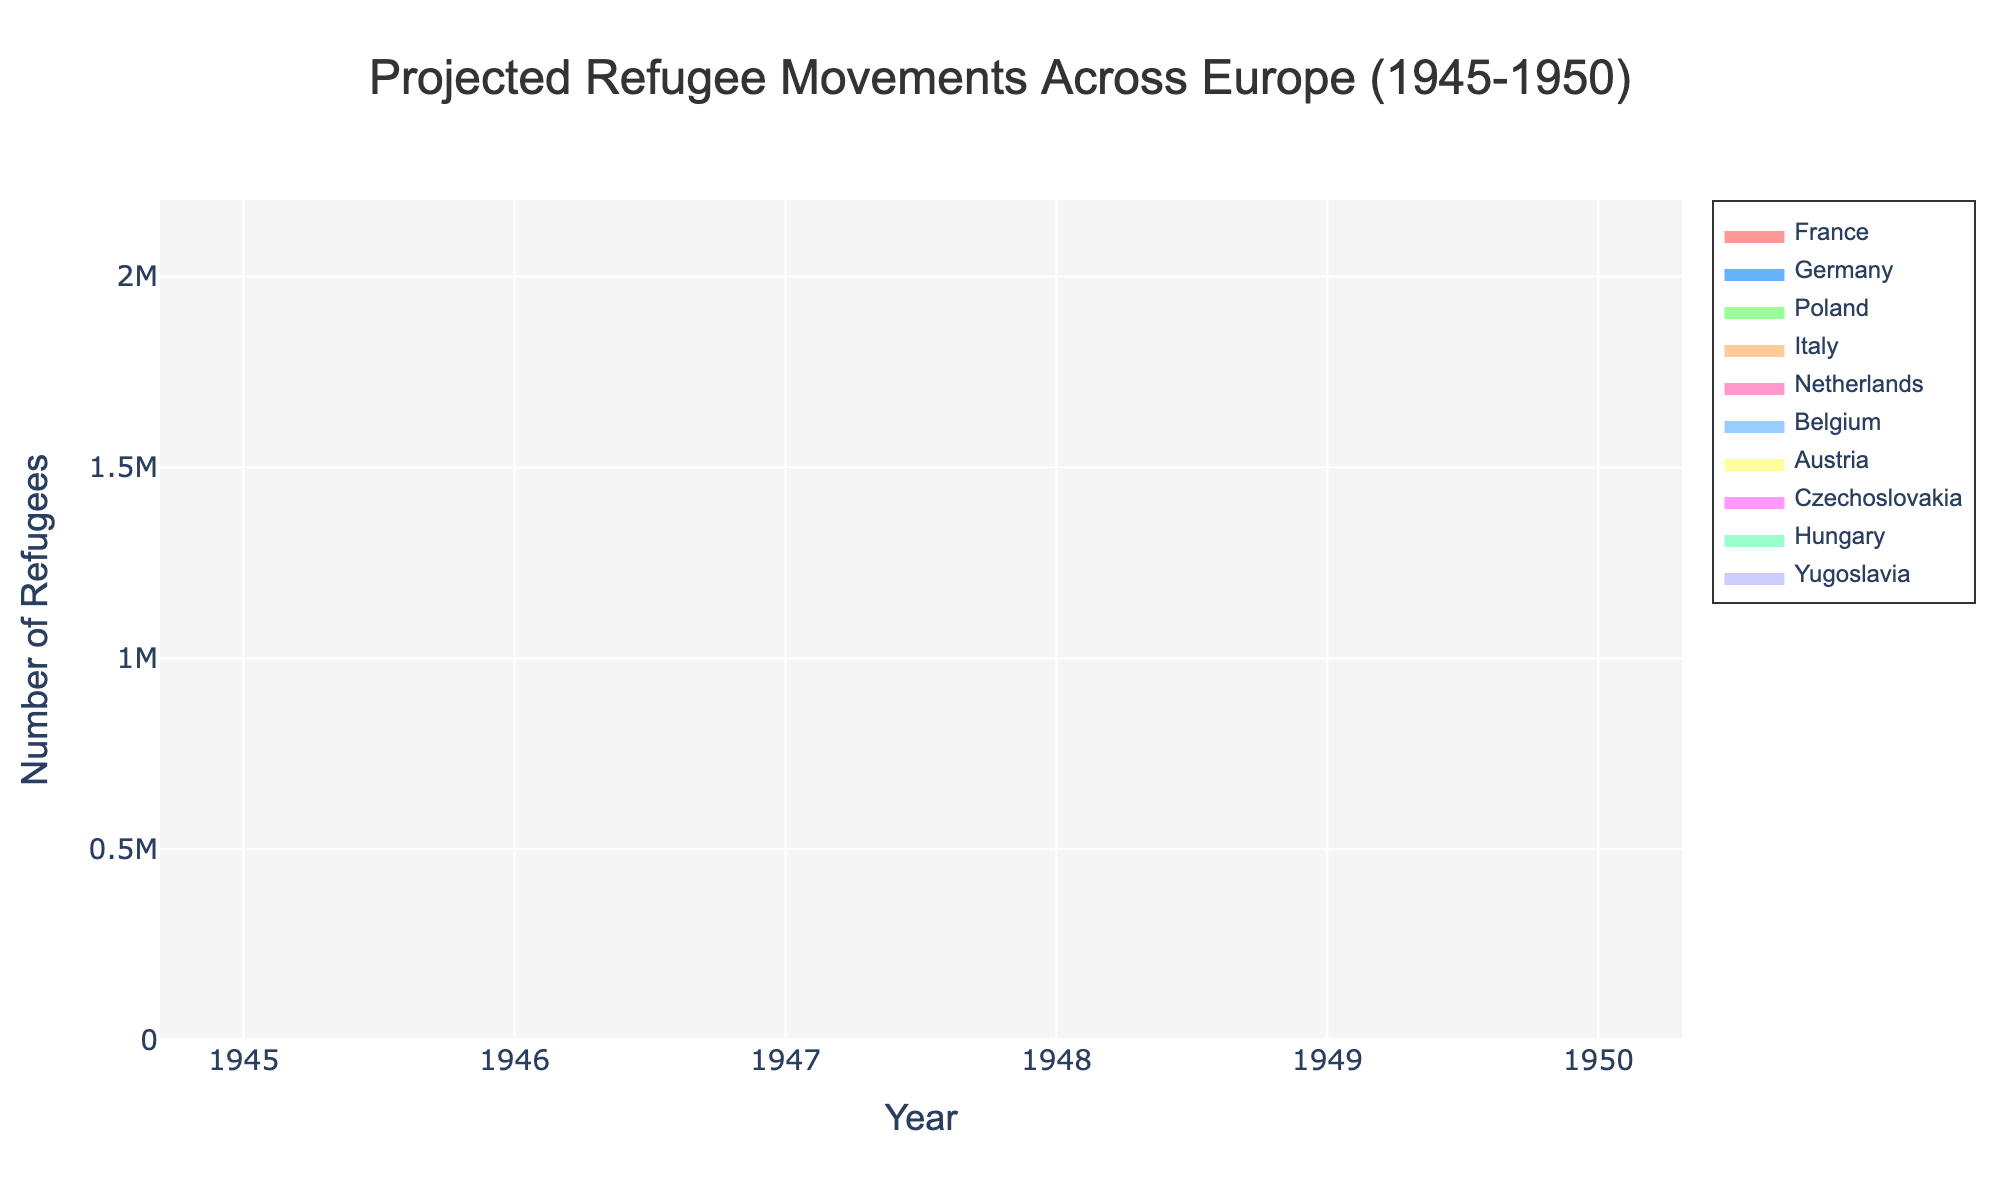What is the total number of refugees in Germany in 1947? In the 1947 column, the number for Germany is 1,600,000.
Answer: 1,600,000 Which country had the lowest number of refugees in 1950? In the 1950 column, Belgium and Italy both share the lowest value of 50,000. This can be cross-validated by scanning all values in the 1950 column.
Answer: Belgium and Italy What is the trend for the number of refugees in France from 1945 to 1950? By examining the data points for France from 1945 to 1950 (500,000; 450,000; 400,000; 350,000; 300,000; 250,000), we notice a consistent decrease.
Answer: A consistent decrease Which country had the most significant decrease in the number of refugees from 1945 to 1950? Subtract the number of refugees in 1950 from the number in 1945 for each country: France (250,000), Germany (1,000,000), Poland (1,000,000), Italy (250,000), Netherlands (100,000), Belgium (100,000), Austria (250,000), Czechoslovakia (150,000), Hungary (150,000), Yugoslavia (150,000). Germany and Poland both have the largest decrease of 1,000,000.
Answer: Germany and Poland How many refugees were in Italy and Poland combined in 1948? For 1948, add the number of refugees in Italy (150,000) and Poland (900,000): 150,000 + 900,000 = 1,050,000.
Answer: 1,050,000 Between France and Austria, which country had fewer refugees in 1949? In 1949, France had 300,000 refugees, and Austria had 200,000. Austria had fewer refugees.
Answer: Austria Which year saw the most significant drop in the number of refugees in Czechoslovakia? Calculate the yearly differences for Czechoslovakia: (250,000 - 220,000) = 30,000 (1945-1946), (220,000 - 190,000) = 30,000 (1946-1947), (190,000 - 160,000) = 30,000 (1947-1948), (160,000 - 130,000) = 30,000 (1948-1949), (130,000 - 100,000) = 30,000 (1949-1950). Each year shows an equal drop of 30,000.
Answer: Each year shows an equal drop of 30,000 In which year did the number of refugees in Hungary drop below 200,000? By checking the numbers for Hungary: 1945 (300,000), 1946 (270,000), 1947 (240,000), 1948 (210,000), 1949 (180,000), the number drops below 200,000 in 1949.
Answer: 1949 What was the average number of refugees in the Netherlands from 1945 to 1950? Sum up the values for the Netherlands (200,000; 180,000; 160,000; 140,000; 120,000; 100,000) and divide by the number of years: (200,000 + 180,000 + 160,000 + 140,000 + 120,000 + 100,000) / 6 = 900,000 / 6 = 150,000.
Answer: 150,000 What was the most common pattern of refugee numbers among all countries from 1945 to 1950? By observing all patterns, we see that the refugee numbers for most countries show a consistent yearly decrease.
Answer: A consistent yearly decrease 